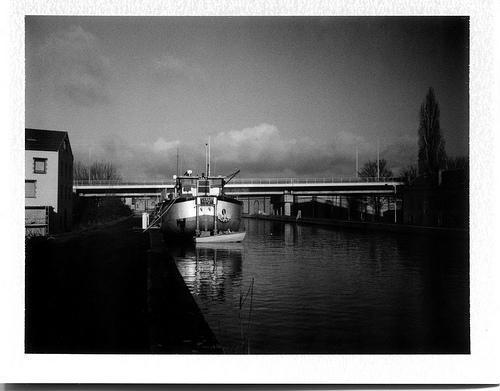How many boats are in the water?
Give a very brief answer. 1. 